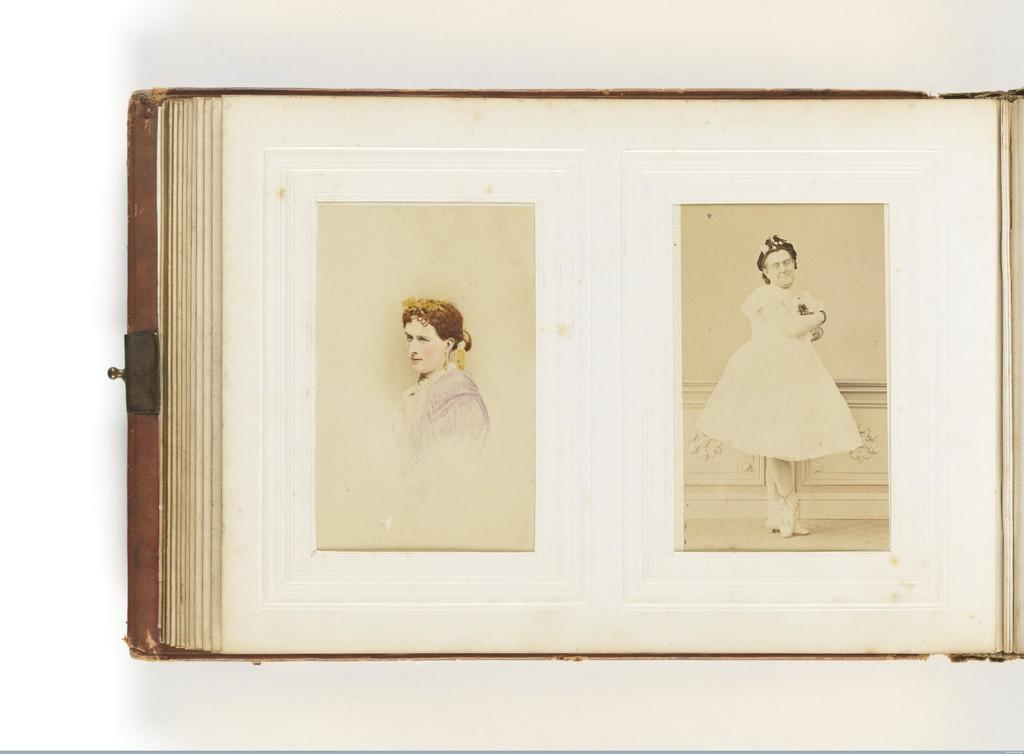What is the main object in the image? There is a book in the image. What can be seen on the papers inside the book? There are pictures of people on the papers. What color is the background of the image? The background of the image is white. How much was the payment for the notebook in the image? There is no payment or notebook present in the image; it only features a book with pictures of people on the papers. 